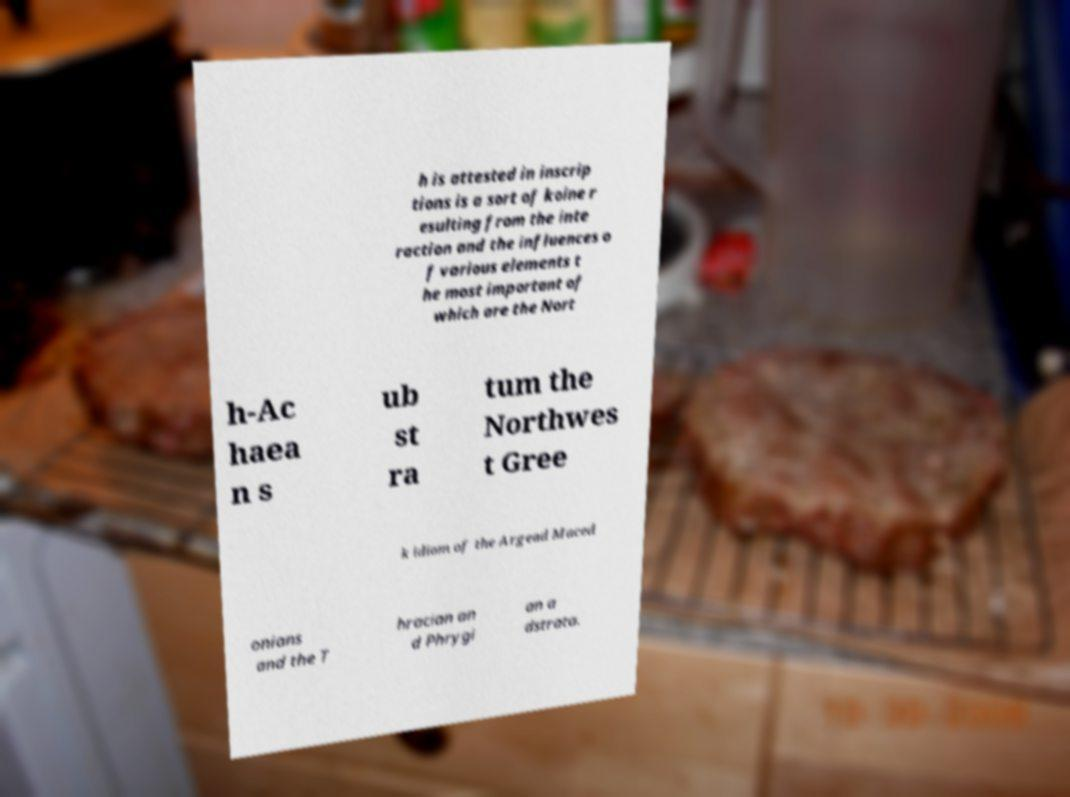Could you extract and type out the text from this image? h is attested in inscrip tions is a sort of koine r esulting from the inte raction and the influences o f various elements t he most important of which are the Nort h-Ac haea n s ub st ra tum the Northwes t Gree k idiom of the Argead Maced onians and the T hracian an d Phrygi an a dstrata. 